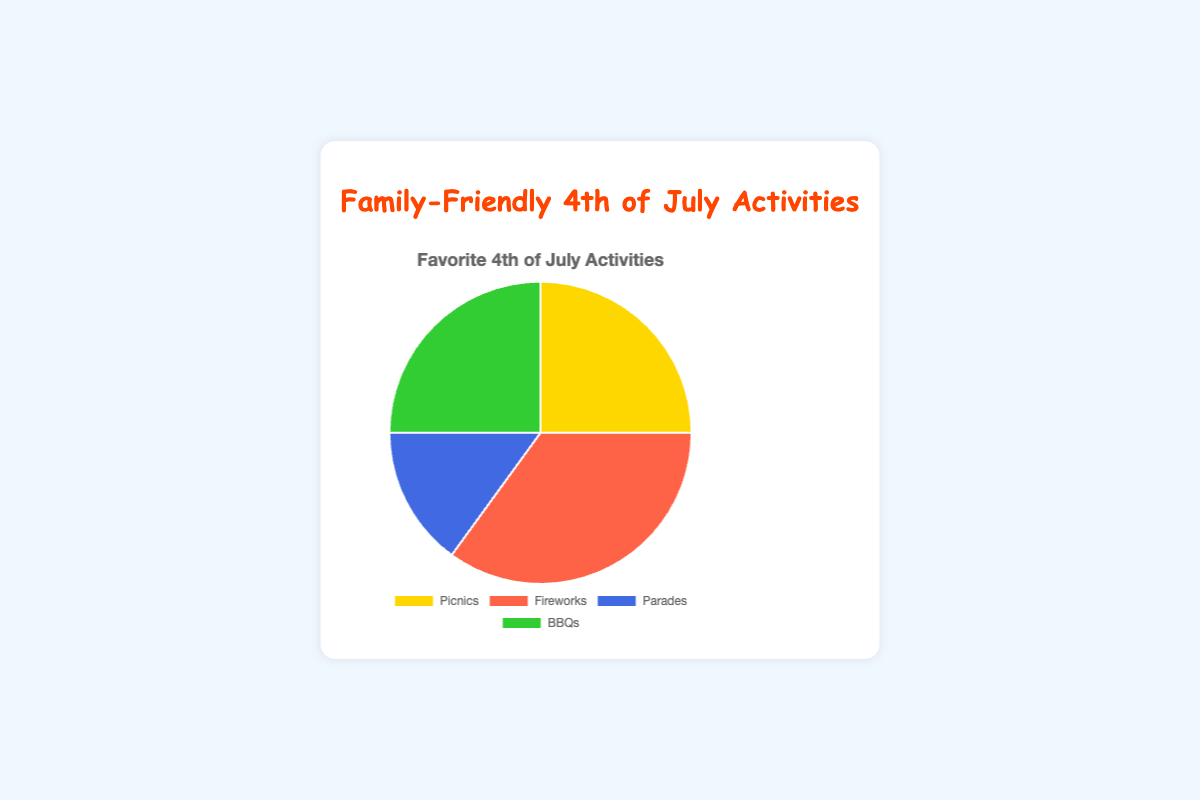What activities fall under 35%? The chart shows "Fireworks" occupying the largest slice, which is 35%.
Answer: Fireworks Which activities occupy an equal percentage of the chart? By observing the chart, it's clear that "Picnics" and "BBQs" occupy equal slices, both having 25% each.
Answer: Picnics, BBQs How do Parades compare to Picnics in terms of percentage? The chart indicates that "Picnics" have a larger percentage (25%) compared to "Parades" (15%). The difference is 25%-15%=10%.
Answer: Picnics have 10% more What is the total percentage of BBQs and Fireworks combined? To find the combined percentage of BBQs and Fireworks, add their individual percentages: 25% (BBQs) + 35% (Fireworks) = 60%.
Answer: 60% What is the average percentage of the activities? Adding all percentages: 25% + 35% + 15% + 25% = 100%. There are 4 activities, so the average is 100% / 4 = 25%.
Answer: 25% Which activity has the smallest percentage and what is its color on the chart? Observing the chart, "Parades" have the smallest percentage (15%) and they are represented by the blue color.
Answer: Parades, blue If another activity was added that took up 10% of the chart, what would be the new percentage for Fireworks? Currently, Fireworks occupy 35%. Adding a new activity at 10% would make the total 110%. To find the new percentage: (35 / 110) * 100 = 31.82%.
Answer: 31.82% What percentage do activities other than Fireworks cover in total? Summing the percentages of activities other than Fireworks: 25% (Picnics) + 15% (Parades) + 25% (BBQs) = 65%.
Answer: 65% 